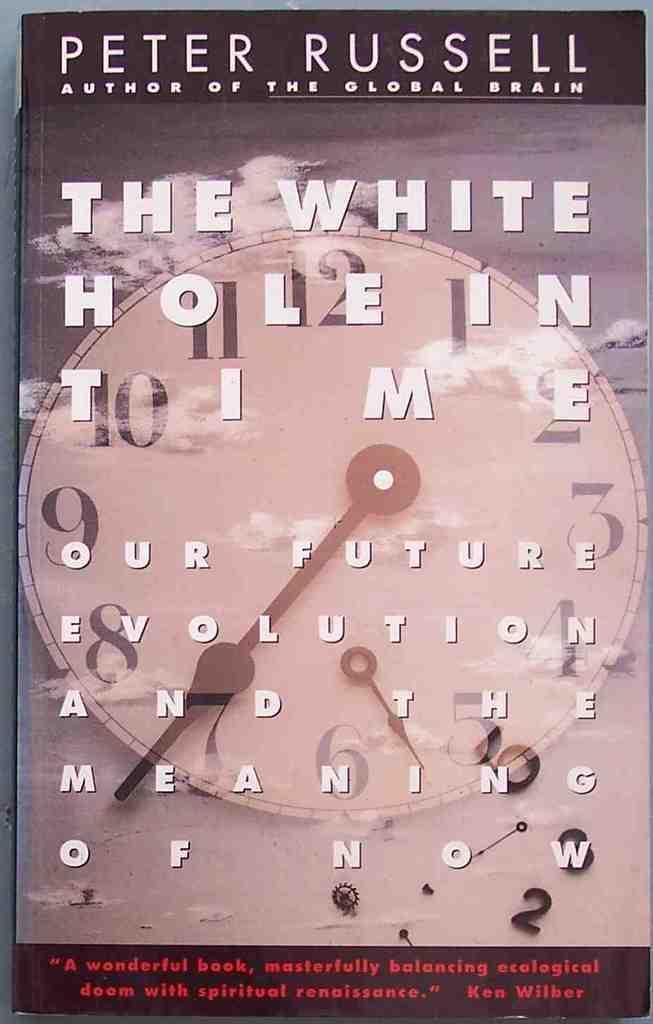Could you give a brief overview of what you see in this image? In the image we can see a book and this is a front page of the book. This is a printed text, clock, and a sky. 